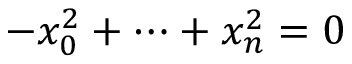Convert formula to latex. <formula><loc_0><loc_0><loc_500><loc_500>- x _ { 0 } ^ { 2 } + \cdots + x _ { n } ^ { 2 } = 0</formula> 